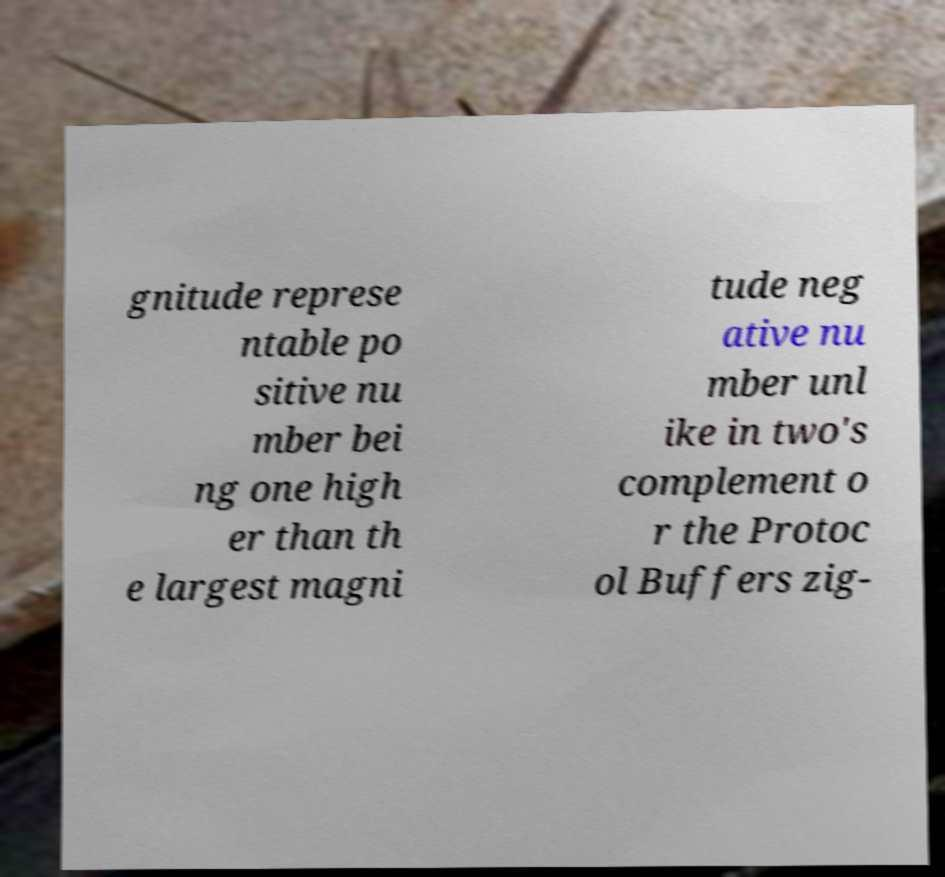What messages or text are displayed in this image? I need them in a readable, typed format. gnitude represe ntable po sitive nu mber bei ng one high er than th e largest magni tude neg ative nu mber unl ike in two's complement o r the Protoc ol Buffers zig- 